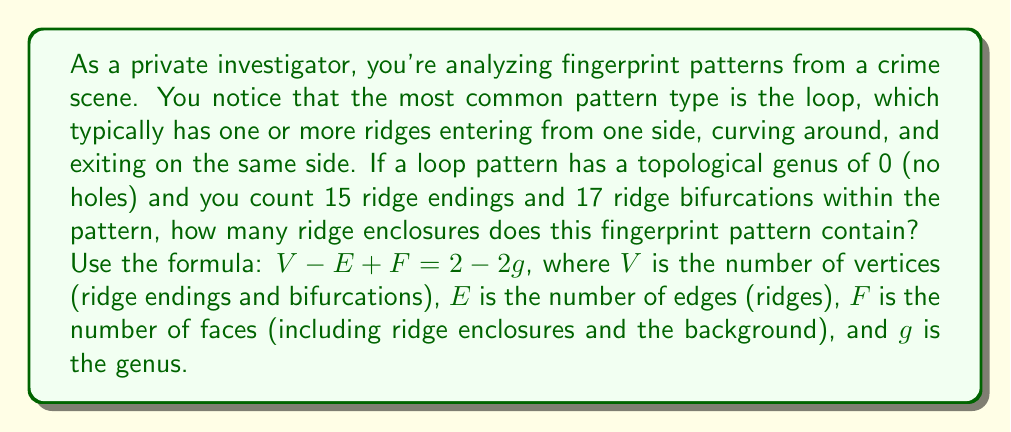What is the answer to this math problem? Let's approach this step-by-step:

1) First, we need to understand what each variable represents in our fingerprint pattern:
   - $V$ (vertices): Ridge endings and bifurcations
   - $E$ (edges): Ridges
   - $F$ (faces): Ridge enclosures plus the background (which counts as one face)
   - $g$ (genus): Given as 0 (no holes)

2) We're given:
   - 15 ridge endings
   - 17 ridge bifurcations
   - Genus $g = 0$

3) Let's calculate $V$:
   $V = 15 + 17 = 32$

4) We can use the Euler-Poincaré formula: $V - E + F = 2 - 2g$

5) Substituting our known values:
   $32 - E + F = 2 - 2(0)$
   $32 - E + F = 2$

6) Now, we need to find a relationship between $E$ and $F$. In a fingerprint pattern:
   - Each ridge ending contributes 1 to $E$
   - Each ridge bifurcation contributes 3 to $E$
   - The number of ridges is half the sum of these contributions (as each ridge has two endpoints)

   So, $E = \frac{1}{2}(15 + 3(17)) = \frac{1}{2}(15 + 51) = 33$

7) Substituting this back into our equation:
   $32 - 33 + F = 2$
   $F = 3$

8) Remember, $F$ includes the background as one face. So the number of ridge enclosures is:
   Number of ridge enclosures = $F - 1 = 3 - 1 = 2$

Therefore, this fingerprint pattern contains 2 ridge enclosures.
Answer: 2 ridge enclosures 